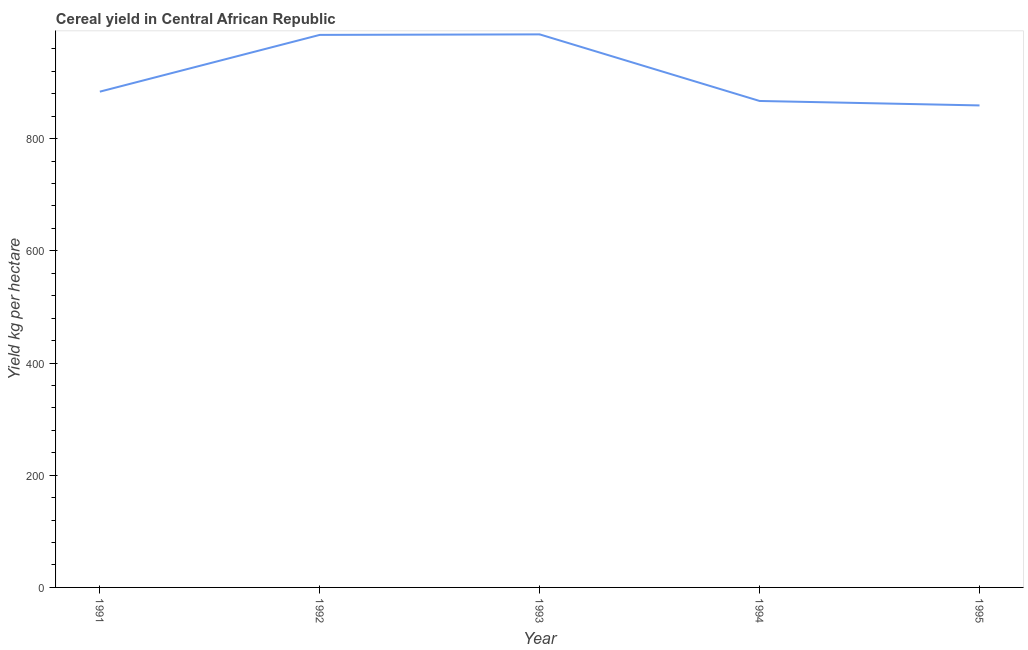What is the cereal yield in 1995?
Provide a succinct answer. 859.19. Across all years, what is the maximum cereal yield?
Ensure brevity in your answer.  985.83. Across all years, what is the minimum cereal yield?
Your response must be concise. 859.19. In which year was the cereal yield minimum?
Your answer should be very brief. 1995. What is the sum of the cereal yield?
Offer a very short reply. 4580.81. What is the difference between the cereal yield in 1993 and 1995?
Your answer should be compact. 126.64. What is the average cereal yield per year?
Make the answer very short. 916.16. What is the median cereal yield?
Offer a terse response. 883.73. Do a majority of the years between 1993 and 1991 (inclusive) have cereal yield greater than 80 kg per hectare?
Make the answer very short. No. What is the ratio of the cereal yield in 1992 to that in 1995?
Provide a succinct answer. 1.15. Is the cereal yield in 1991 less than that in 1992?
Keep it short and to the point. Yes. What is the difference between the highest and the second highest cereal yield?
Your answer should be compact. 0.9. What is the difference between the highest and the lowest cereal yield?
Provide a succinct answer. 126.64. In how many years, is the cereal yield greater than the average cereal yield taken over all years?
Give a very brief answer. 2. Does the cereal yield monotonically increase over the years?
Keep it short and to the point. No. How many lines are there?
Your response must be concise. 1. How many years are there in the graph?
Your response must be concise. 5. What is the difference between two consecutive major ticks on the Y-axis?
Offer a very short reply. 200. Does the graph contain grids?
Provide a short and direct response. No. What is the title of the graph?
Your answer should be compact. Cereal yield in Central African Republic. What is the label or title of the X-axis?
Make the answer very short. Year. What is the label or title of the Y-axis?
Provide a short and direct response. Yield kg per hectare. What is the Yield kg per hectare in 1991?
Offer a terse response. 883.73. What is the Yield kg per hectare of 1992?
Your answer should be very brief. 984.92. What is the Yield kg per hectare in 1993?
Make the answer very short. 985.83. What is the Yield kg per hectare of 1994?
Ensure brevity in your answer.  867.13. What is the Yield kg per hectare of 1995?
Your answer should be compact. 859.19. What is the difference between the Yield kg per hectare in 1991 and 1992?
Ensure brevity in your answer.  -101.19. What is the difference between the Yield kg per hectare in 1991 and 1993?
Offer a terse response. -102.1. What is the difference between the Yield kg per hectare in 1991 and 1994?
Offer a very short reply. 16.6. What is the difference between the Yield kg per hectare in 1991 and 1995?
Your answer should be compact. 24.54. What is the difference between the Yield kg per hectare in 1992 and 1993?
Offer a terse response. -0.91. What is the difference between the Yield kg per hectare in 1992 and 1994?
Give a very brief answer. 117.79. What is the difference between the Yield kg per hectare in 1992 and 1995?
Offer a terse response. 125.73. What is the difference between the Yield kg per hectare in 1993 and 1994?
Offer a terse response. 118.7. What is the difference between the Yield kg per hectare in 1993 and 1995?
Your response must be concise. 126.64. What is the difference between the Yield kg per hectare in 1994 and 1995?
Provide a short and direct response. 7.94. What is the ratio of the Yield kg per hectare in 1991 to that in 1992?
Offer a terse response. 0.9. What is the ratio of the Yield kg per hectare in 1991 to that in 1993?
Offer a terse response. 0.9. What is the ratio of the Yield kg per hectare in 1992 to that in 1994?
Give a very brief answer. 1.14. What is the ratio of the Yield kg per hectare in 1992 to that in 1995?
Your answer should be compact. 1.15. What is the ratio of the Yield kg per hectare in 1993 to that in 1994?
Your answer should be compact. 1.14. What is the ratio of the Yield kg per hectare in 1993 to that in 1995?
Offer a very short reply. 1.15. 